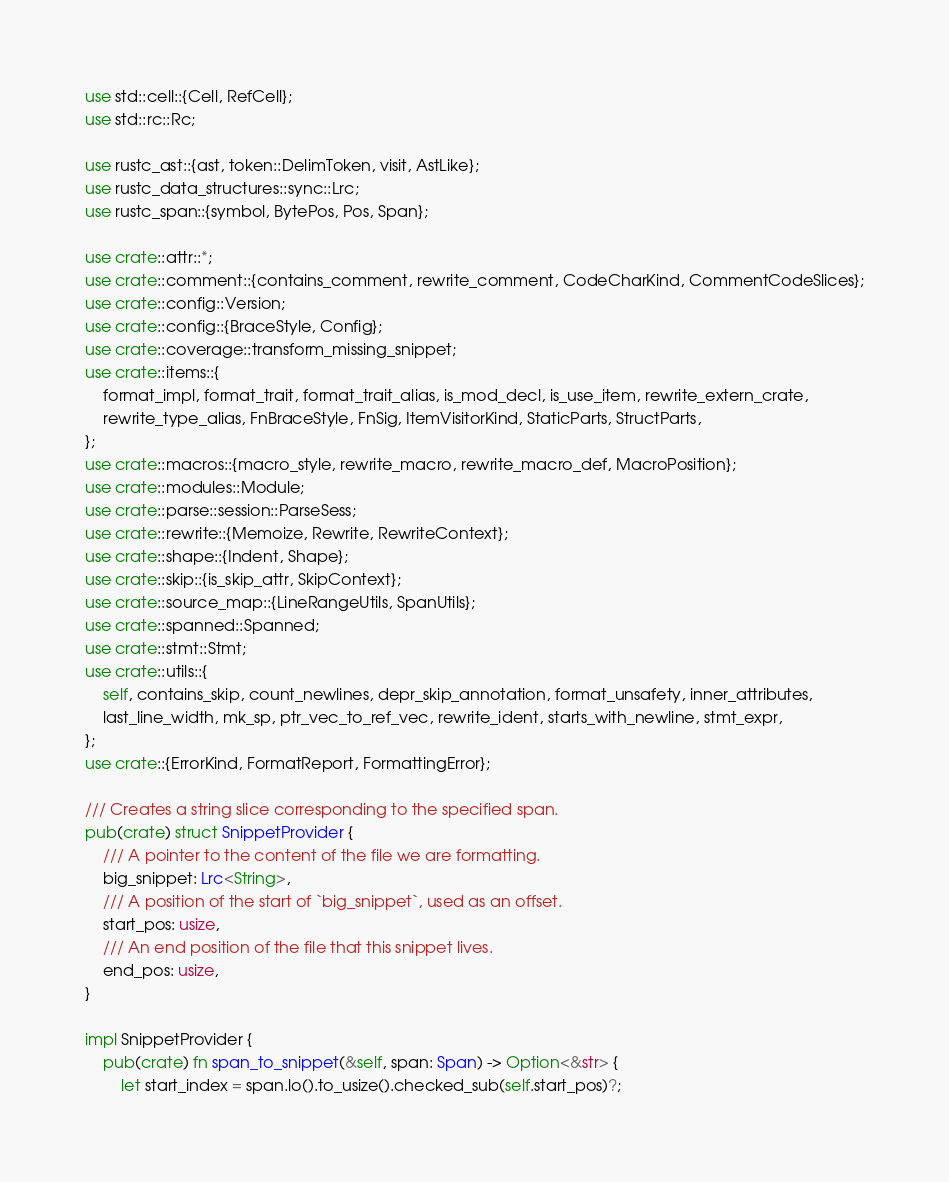Convert code to text. <code><loc_0><loc_0><loc_500><loc_500><_Rust_>use std::cell::{Cell, RefCell};
use std::rc::Rc;

use rustc_ast::{ast, token::DelimToken, visit, AstLike};
use rustc_data_structures::sync::Lrc;
use rustc_span::{symbol, BytePos, Pos, Span};

use crate::attr::*;
use crate::comment::{contains_comment, rewrite_comment, CodeCharKind, CommentCodeSlices};
use crate::config::Version;
use crate::config::{BraceStyle, Config};
use crate::coverage::transform_missing_snippet;
use crate::items::{
    format_impl, format_trait, format_trait_alias, is_mod_decl, is_use_item, rewrite_extern_crate,
    rewrite_type_alias, FnBraceStyle, FnSig, ItemVisitorKind, StaticParts, StructParts,
};
use crate::macros::{macro_style, rewrite_macro, rewrite_macro_def, MacroPosition};
use crate::modules::Module;
use crate::parse::session::ParseSess;
use crate::rewrite::{Memoize, Rewrite, RewriteContext};
use crate::shape::{Indent, Shape};
use crate::skip::{is_skip_attr, SkipContext};
use crate::source_map::{LineRangeUtils, SpanUtils};
use crate::spanned::Spanned;
use crate::stmt::Stmt;
use crate::utils::{
    self, contains_skip, count_newlines, depr_skip_annotation, format_unsafety, inner_attributes,
    last_line_width, mk_sp, ptr_vec_to_ref_vec, rewrite_ident, starts_with_newline, stmt_expr,
};
use crate::{ErrorKind, FormatReport, FormattingError};

/// Creates a string slice corresponding to the specified span.
pub(crate) struct SnippetProvider {
    /// A pointer to the content of the file we are formatting.
    big_snippet: Lrc<String>,
    /// A position of the start of `big_snippet`, used as an offset.
    start_pos: usize,
    /// An end position of the file that this snippet lives.
    end_pos: usize,
}

impl SnippetProvider {
    pub(crate) fn span_to_snippet(&self, span: Span) -> Option<&str> {
        let start_index = span.lo().to_usize().checked_sub(self.start_pos)?;</code> 